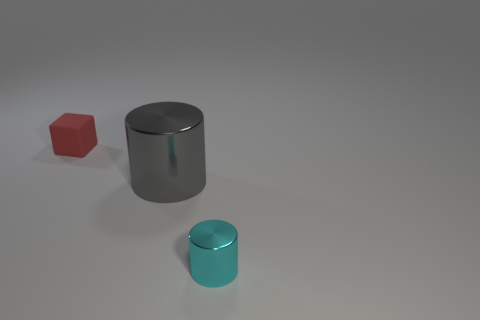Add 2 large yellow rubber objects. How many objects exist? 5 Subtract all cylinders. How many objects are left? 1 Add 3 tiny cubes. How many tiny cubes are left? 4 Add 1 gray cylinders. How many gray cylinders exist? 2 Subtract 0 red spheres. How many objects are left? 3 Subtract all tiny cyan metal things. Subtract all gray objects. How many objects are left? 1 